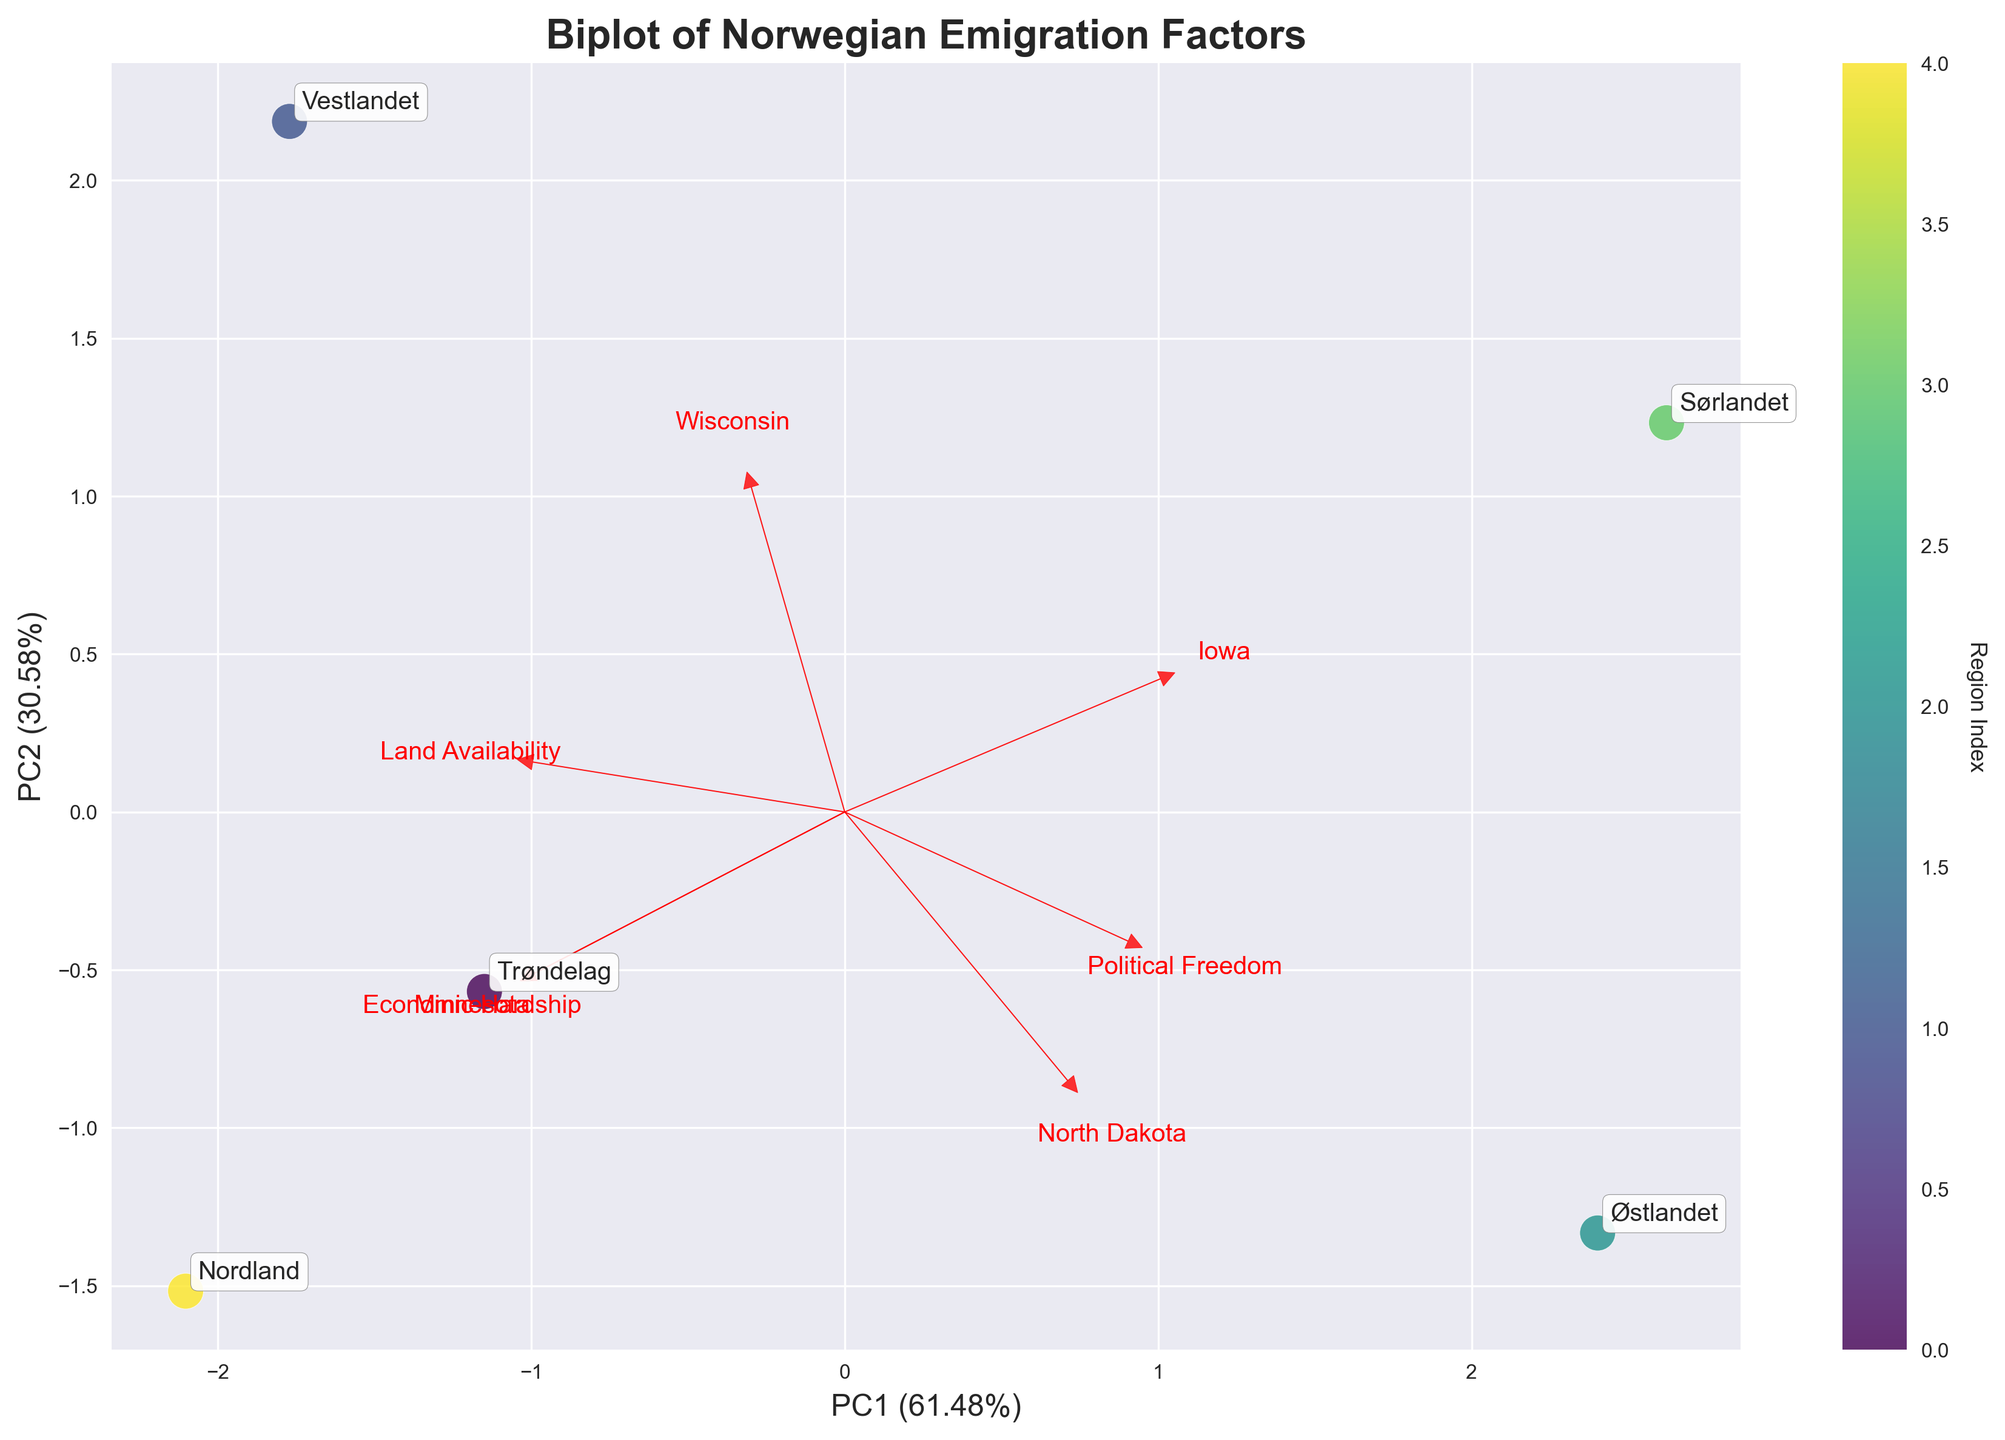What's the title of the figure? The title of the figure is located at the top and gives an overview of what the visual is about.
Answer: Biplot of Norwegian Emigration Factors What percentage of the variance is explained by the first principal component (PC1)? The x-axis label specifies the variance percentage explained by PC1.
Answer: 45.5% Which region is most closely associated with high economic hardship? Examine the position of the regions relative to the 'Economic Hardship' vector (red arrow). The region situated closest to the direction of this vector is most associated with high economic hardship.
Answer: Nordland How many regions are plotted in the figure? Each region is represented as a point in the plot and annotated with its name. Count the annotations to find the total number of regions.
Answer: 5 Which factor has the largest positive loading on PC1? Look at the vectors (arrows) labeled with factors and identify which one points most directly along the positive direction of PC1.
Answer: Economic Hardship Which of the plotted cities appears to be more associated with regions experiencing economic hardship and political freedom? Identify which city is positioned closest in the same quadrant or direction as both 'Economic Hardship' and 'Political Freedom' vectors.
Answer: Minnesota Considering geographical diversity, which regions in Norway have a strong association with both 'Land Availability' and emigrating to 'Wisconsin'? Look for regions that lie in the direction of both 'Land Availability' and 'Wisconsin' vectors.
Answer: Vestlandet How are 'Nordland' and 'Trøndelag' similar in terms of emigration factors? Compare the positions of 'Nordland' and 'Trøndelag' in the plot to see if they align similarly with any of the factors. They both lie in the general direction of 'Economic Hardship' vector.
Answer: High economic hardship Which two destination choices appear to have the least influence on the first two principal components? Identify the destination choices whose vectors are shortest, indicating minimal contribution to the variance in PC1 and PC2.
Answer: Iowa and North Dakota Which factor contributes most to the explained variance along PC2? Identify the vector that points most directly along the positive or negative direction of PC2.
Answer: Political Freedom 